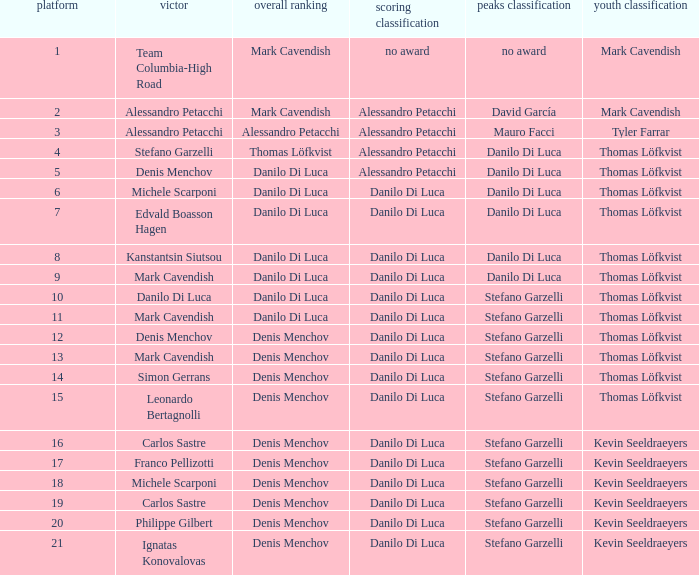When thomas löfkvist participates in the general classification, who is declared the victor? Stefano Garzelli. 